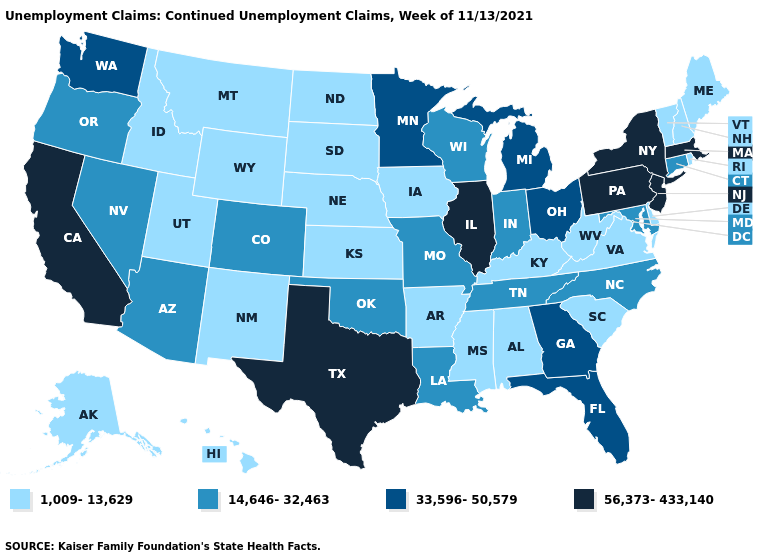What is the value of Arkansas?
Short answer required. 1,009-13,629. Does Iowa have the lowest value in the USA?
Concise answer only. Yes. Does Vermont have the lowest value in the Northeast?
Be succinct. Yes. Which states have the lowest value in the USA?
Concise answer only. Alabama, Alaska, Arkansas, Delaware, Hawaii, Idaho, Iowa, Kansas, Kentucky, Maine, Mississippi, Montana, Nebraska, New Hampshire, New Mexico, North Dakota, Rhode Island, South Carolina, South Dakota, Utah, Vermont, Virginia, West Virginia, Wyoming. Name the states that have a value in the range 56,373-433,140?
Short answer required. California, Illinois, Massachusetts, New Jersey, New York, Pennsylvania, Texas. What is the value of Oregon?
Answer briefly. 14,646-32,463. Does Alabama have the lowest value in the South?
Concise answer only. Yes. What is the value of Kentucky?
Short answer required. 1,009-13,629. What is the value of Illinois?
Answer briefly. 56,373-433,140. What is the lowest value in states that border Maine?
Concise answer only. 1,009-13,629. Among the states that border Maryland , does Pennsylvania have the lowest value?
Give a very brief answer. No. What is the lowest value in states that border New York?
Concise answer only. 1,009-13,629. Does the first symbol in the legend represent the smallest category?
Give a very brief answer. Yes. Which states have the lowest value in the MidWest?
Concise answer only. Iowa, Kansas, Nebraska, North Dakota, South Dakota. Which states have the highest value in the USA?
Be succinct. California, Illinois, Massachusetts, New Jersey, New York, Pennsylvania, Texas. 